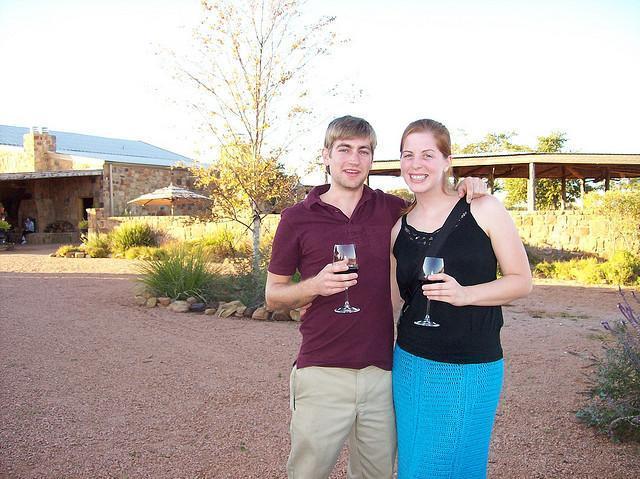How many people are in the picture?
Give a very brief answer. 2. How many red vases are in the picture?
Give a very brief answer. 0. 